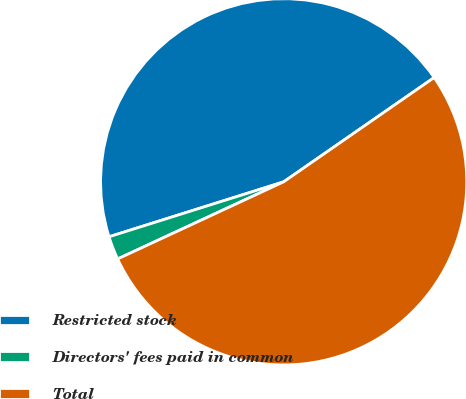<chart> <loc_0><loc_0><loc_500><loc_500><pie_chart><fcel>Restricted stock<fcel>Directors' fees paid in common<fcel>Total<nl><fcel>45.21%<fcel>2.07%<fcel>52.73%<nl></chart> 